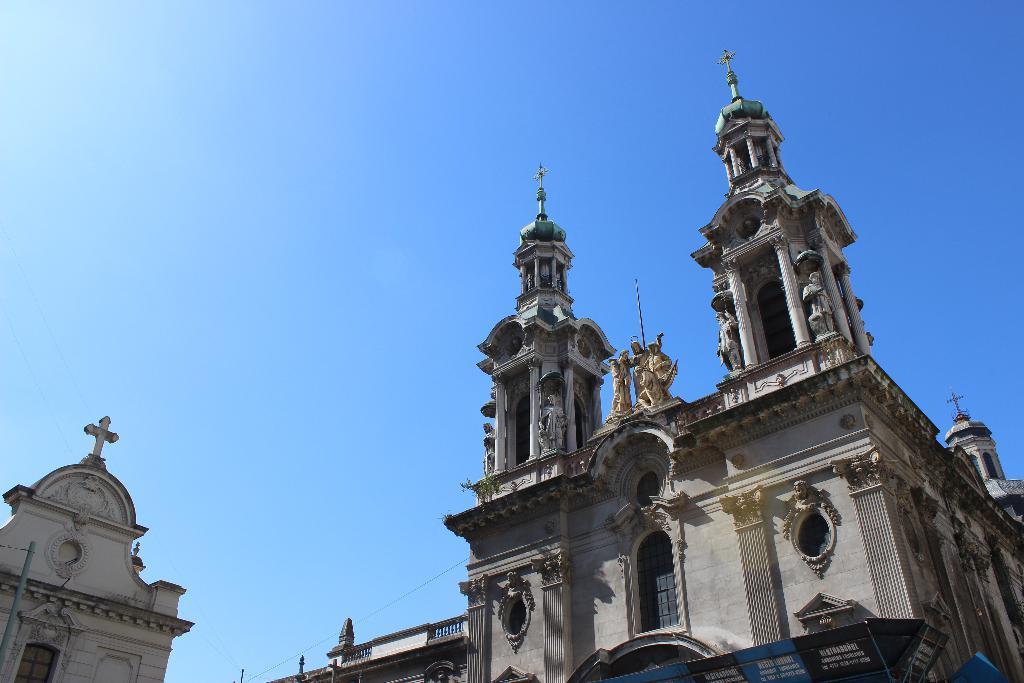In one or two sentences, can you explain what this image depicts? In this picture we can observe a building. There are some statues on the top of the building. We can observe pillars and two towers. On the left side there is a cross on the top of this building. In the background there is a sky. 